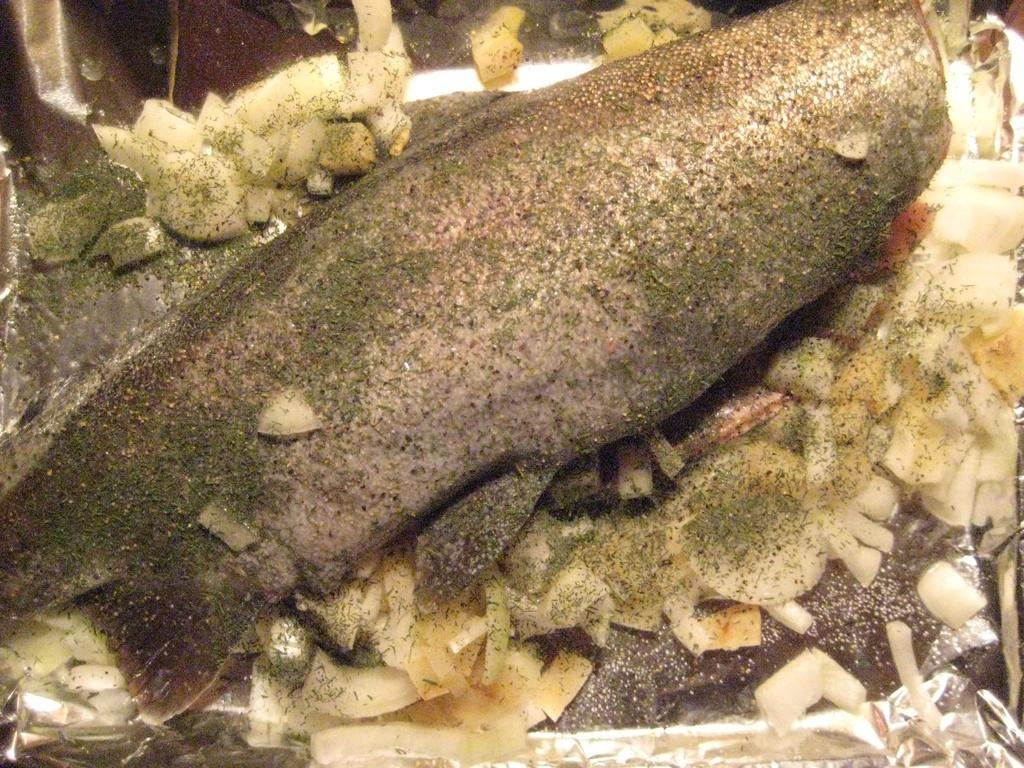What type of animal is in the image? There is a fish in the image. What might be the purpose of the fish in the image? The fish appears to be food. What type of battle is depicted in the image involving the fish? There is no battle depicted in the image; it only features a fish that appears to be food. 